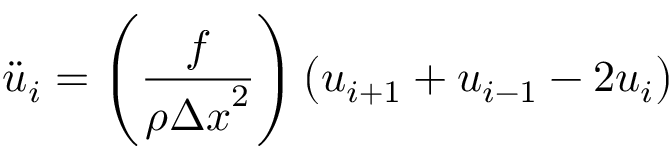Convert formula to latex. <formula><loc_0><loc_0><loc_500><loc_500>{ \ddot { u } } _ { i } = \left ( { \frac { f } { \rho { \Delta x } ^ { 2 } } } \right ) \left ( u _ { i + 1 } + u _ { i - 1 } - 2 u _ { i } \right )</formula> 